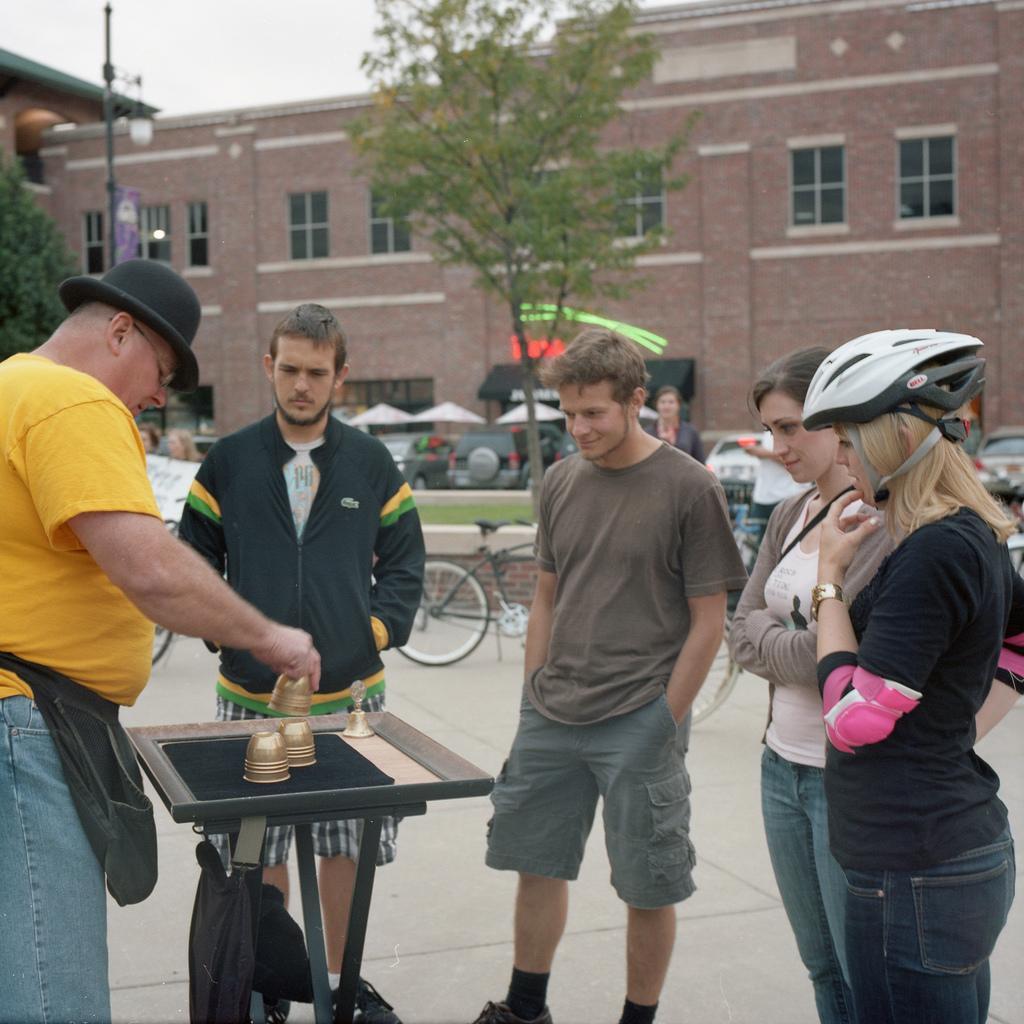Describe this image in one or two sentences. In this image I can see people are standing among them this woman is wearing a helmet. Here I can see a table which has same objects on it. In the background I can see a building, a bicycle, trees, stalls and the sky. 